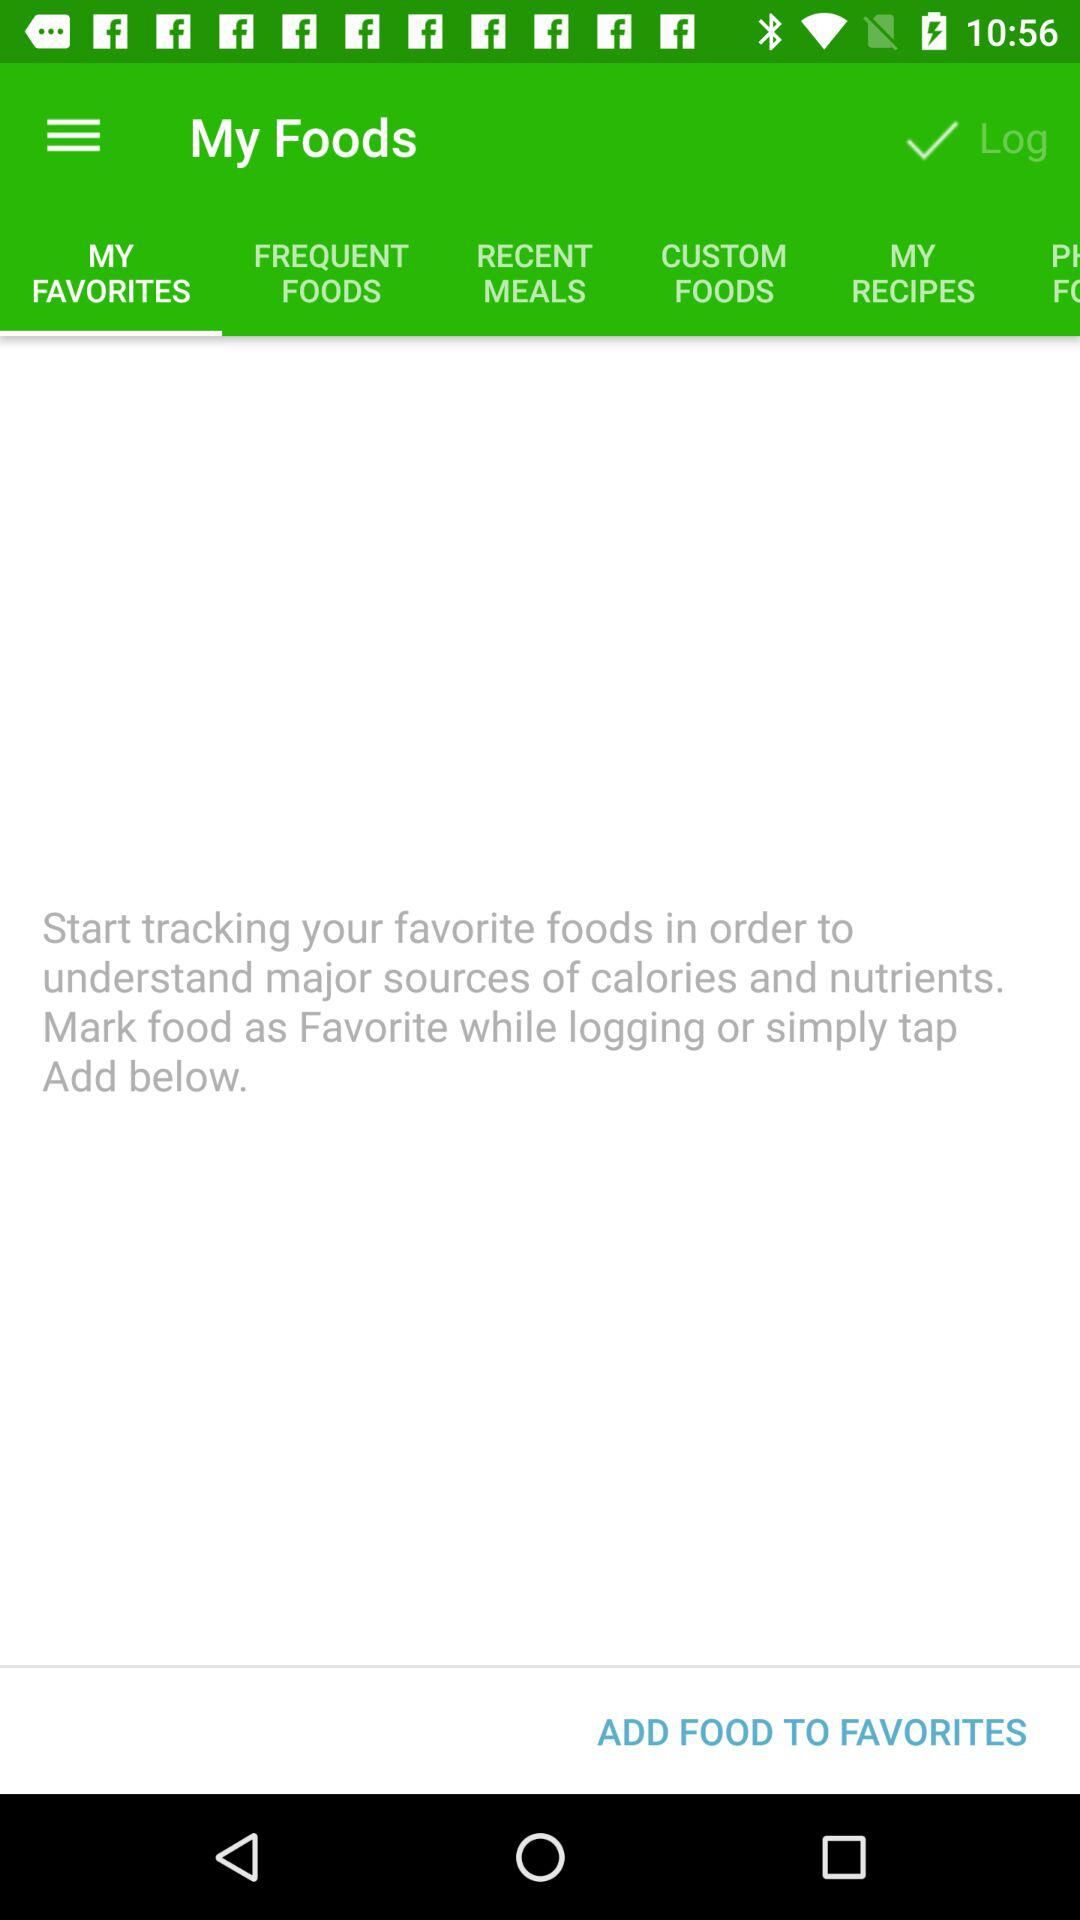Which tab am I using? You are using the "MY FAVORITES" tab. 